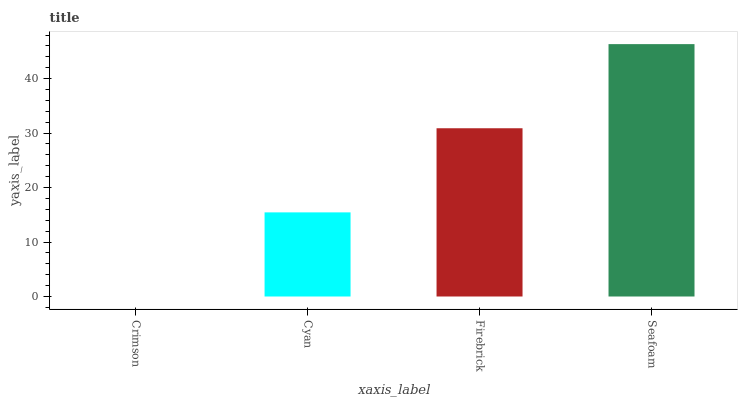Is Crimson the minimum?
Answer yes or no. Yes. Is Seafoam the maximum?
Answer yes or no. Yes. Is Cyan the minimum?
Answer yes or no. No. Is Cyan the maximum?
Answer yes or no. No. Is Cyan greater than Crimson?
Answer yes or no. Yes. Is Crimson less than Cyan?
Answer yes or no. Yes. Is Crimson greater than Cyan?
Answer yes or no. No. Is Cyan less than Crimson?
Answer yes or no. No. Is Firebrick the high median?
Answer yes or no. Yes. Is Cyan the low median?
Answer yes or no. Yes. Is Seafoam the high median?
Answer yes or no. No. Is Firebrick the low median?
Answer yes or no. No. 